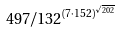Convert formula to latex. <formula><loc_0><loc_0><loc_500><loc_500>4 9 7 / 1 3 2 ^ { ( 7 \cdot 1 5 2 ) ^ { \sqrt { 2 0 2 } } }</formula> 